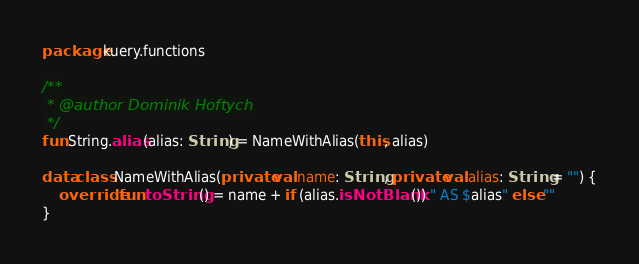<code> <loc_0><loc_0><loc_500><loc_500><_Kotlin_>package kuery.functions

/**
 * @author Dominik Hoftych
 */
fun String.alias(alias: String) = NameWithAlias(this, alias)

data class NameWithAlias(private val name: String, private val alias: String = "") {
    override fun toString() = name + if (alias.isNotBlank()) " AS $alias" else ""
}
</code> 